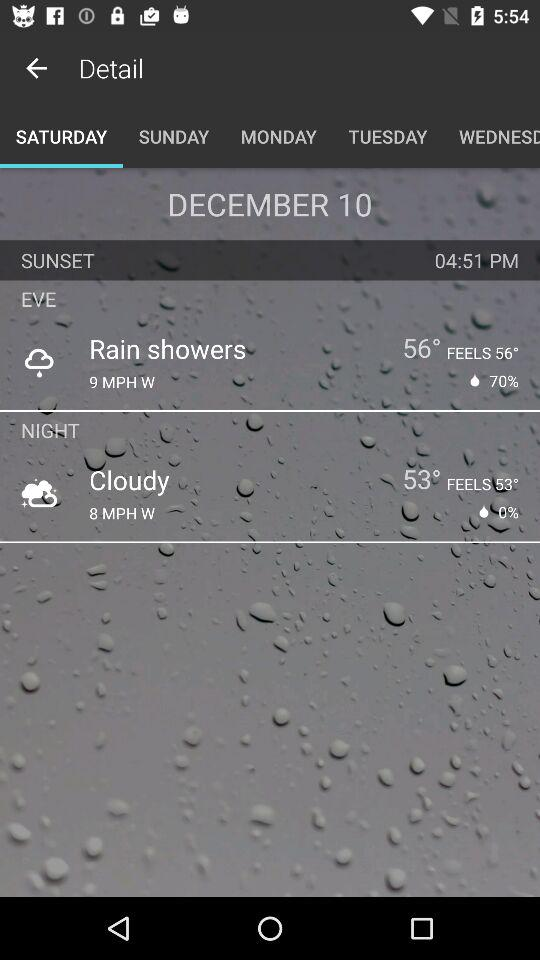What is the temperature in the evening? The temperature in the evening is 56°. 